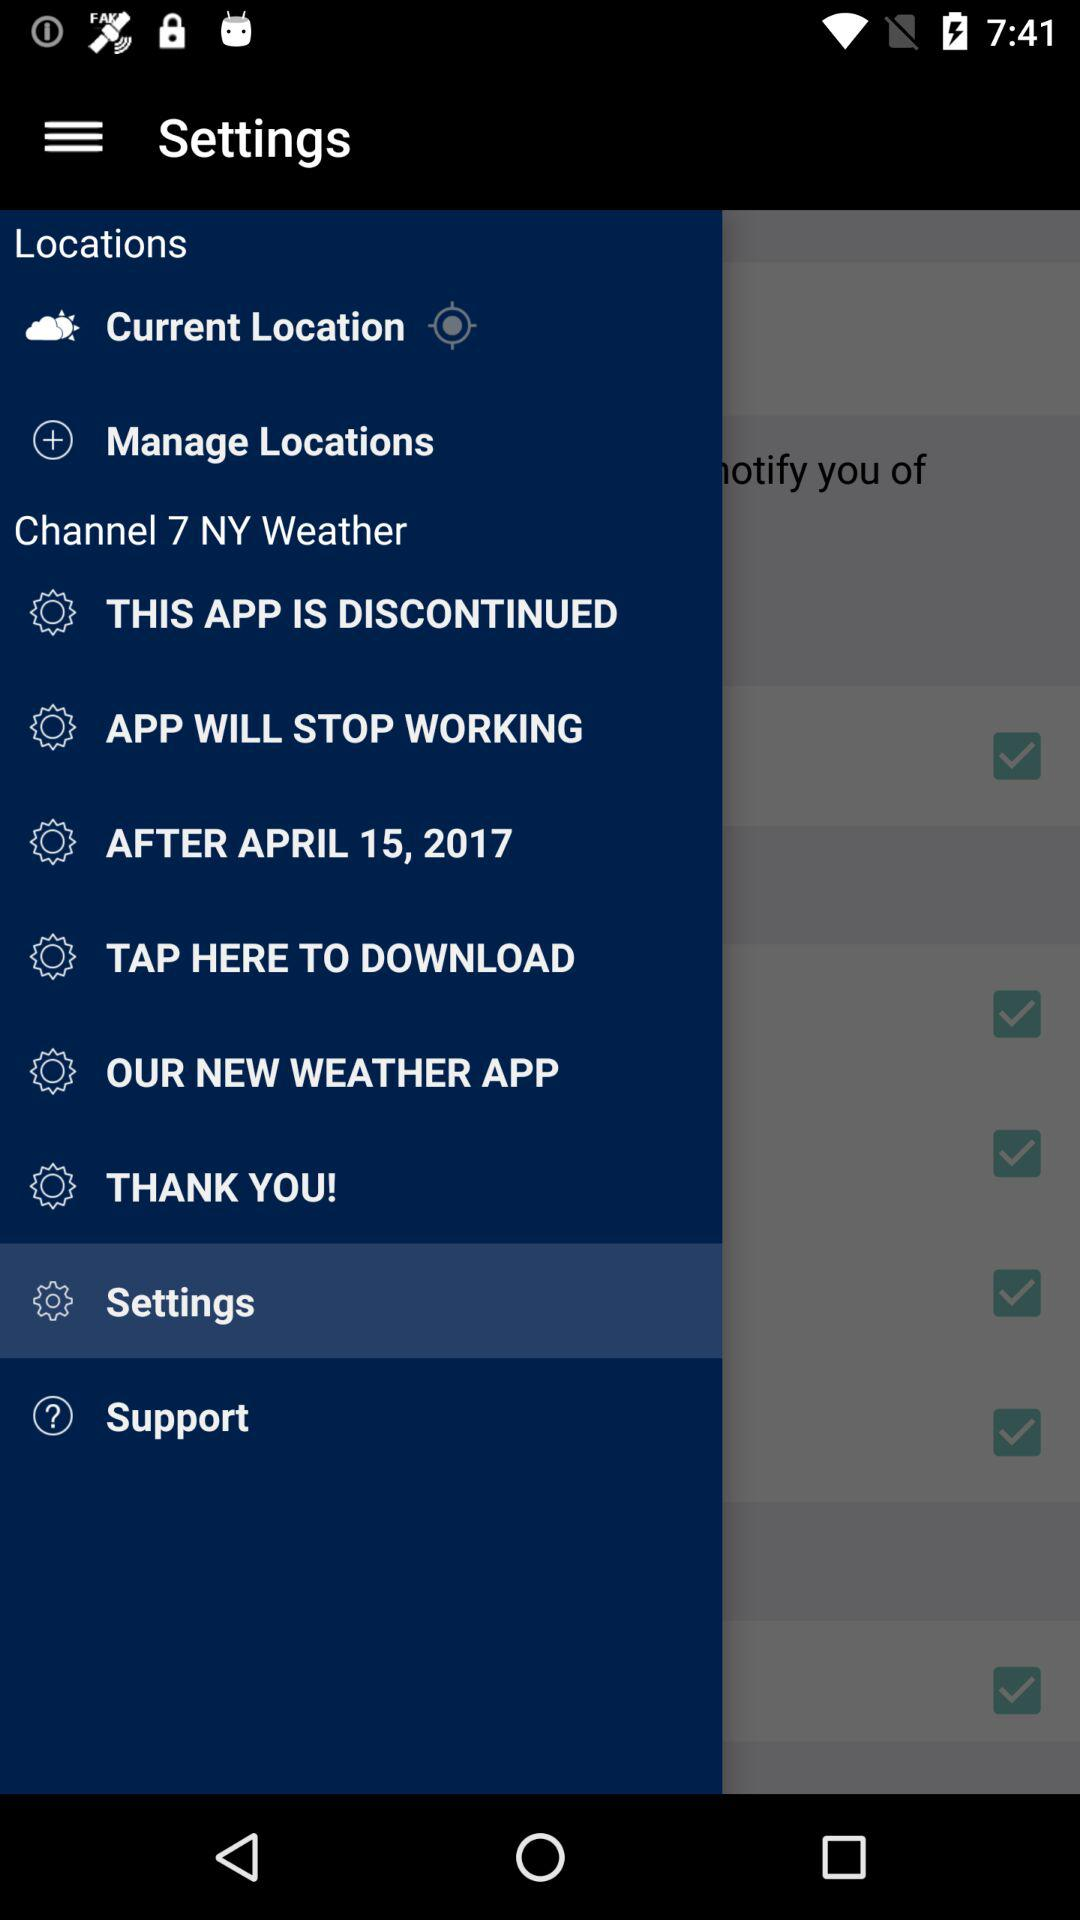What is the channel name? The channel name is "Channel 7 NY Weather". 